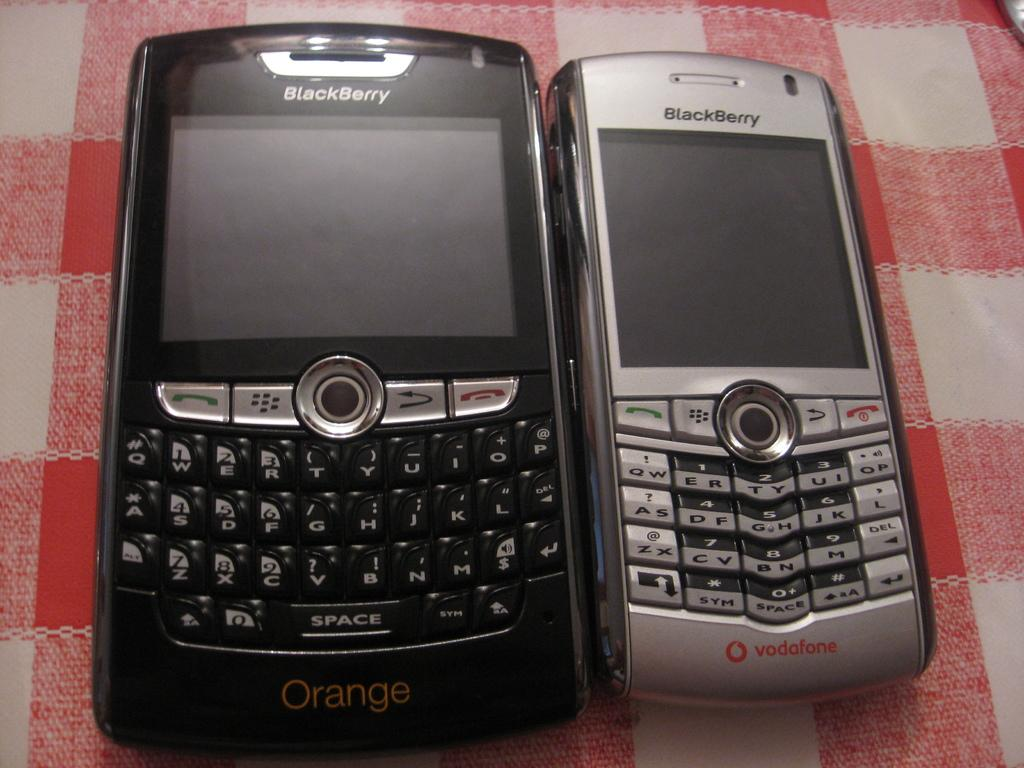<image>
Present a compact description of the photo's key features. Two blackberry phones are side by side on the table. 